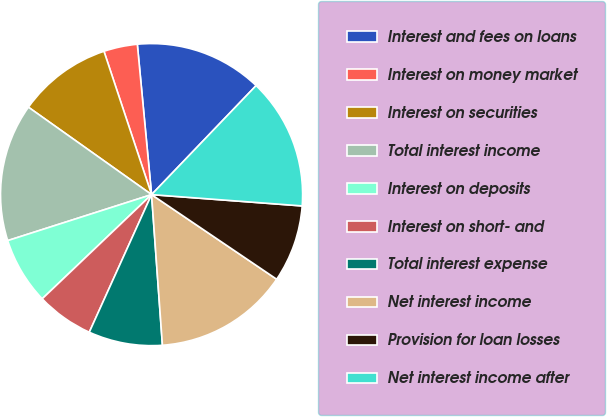<chart> <loc_0><loc_0><loc_500><loc_500><pie_chart><fcel>Interest and fees on loans<fcel>Interest on money market<fcel>Interest on securities<fcel>Total interest income<fcel>Interest on deposits<fcel>Interest on short- and<fcel>Total interest expense<fcel>Net interest income<fcel>Provision for loan losses<fcel>Net interest income after<nl><fcel>13.67%<fcel>3.6%<fcel>10.07%<fcel>14.75%<fcel>7.19%<fcel>6.12%<fcel>7.91%<fcel>14.39%<fcel>8.27%<fcel>14.03%<nl></chart> 